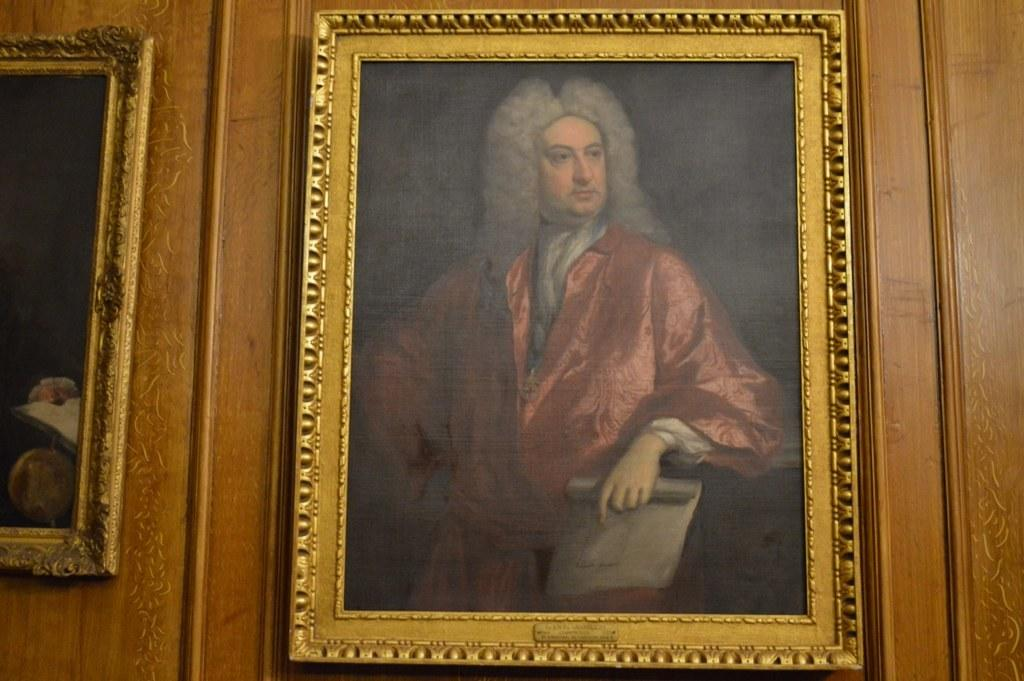What can be seen in the image? There are frames in the image. What is inside one of the frames? One of the frames contains a painting of a man. Where is the kitten sitting in the image? There is no kitten present in the image. What type of beam is supporting the frames in the image? The provided facts do not mention any beams supporting the frames in the image. 